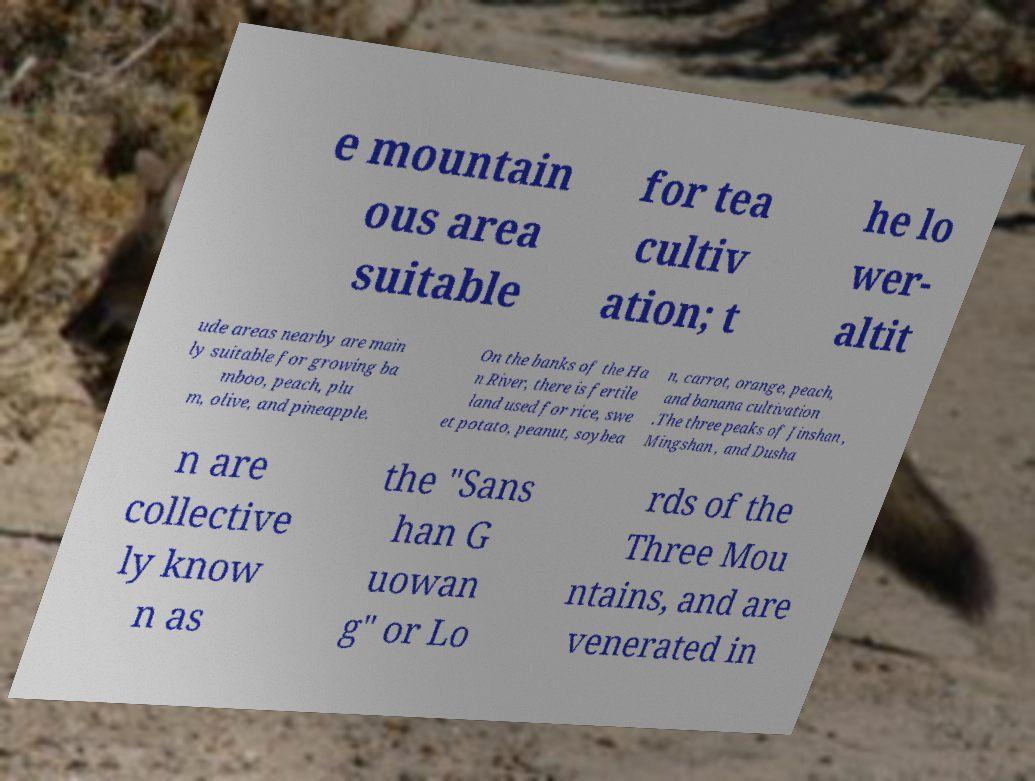Please read and relay the text visible in this image. What does it say? e mountain ous area suitable for tea cultiv ation; t he lo wer- altit ude areas nearby are main ly suitable for growing ba mboo, peach, plu m, olive, and pineapple. On the banks of the Ha n River, there is fertile land used for rice, swe et potato, peanut, soybea n, carrot, orange, peach, and banana cultivation .The three peaks of Jinshan , Mingshan , and Dusha n are collective ly know n as the "Sans han G uowan g" or Lo rds of the Three Mou ntains, and are venerated in 